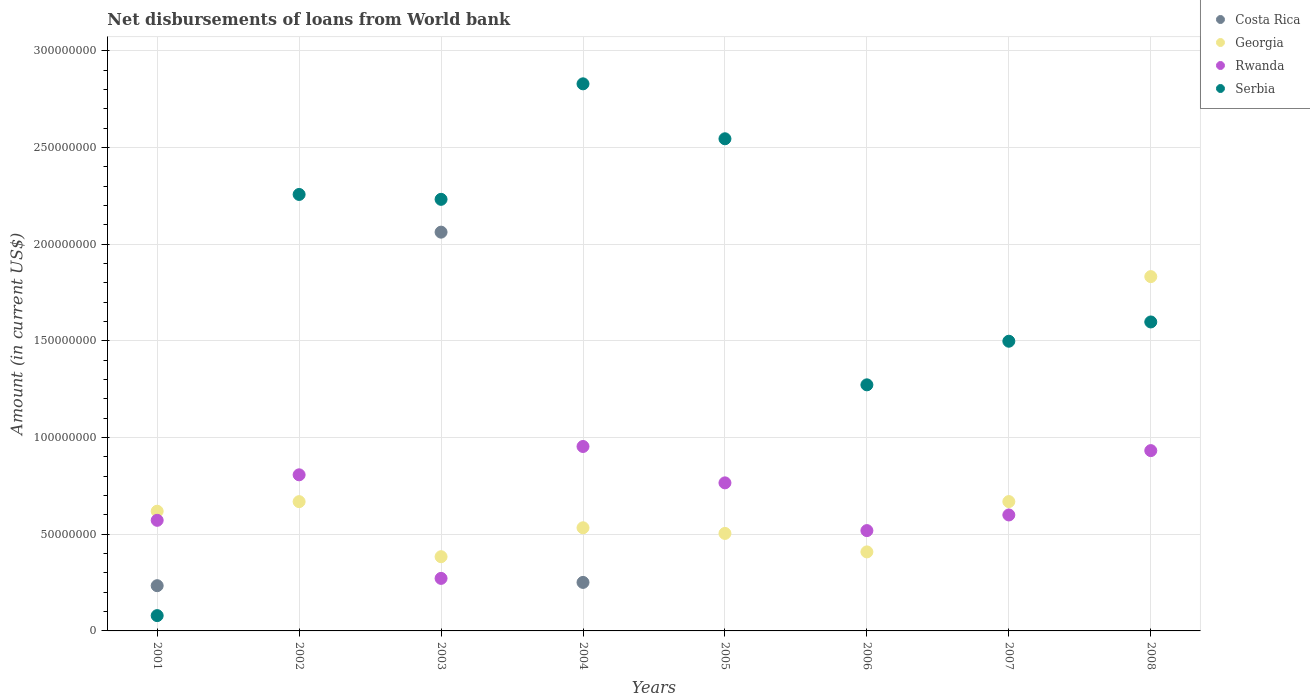What is the amount of loan disbursed from World Bank in Rwanda in 2008?
Your response must be concise. 9.32e+07. Across all years, what is the maximum amount of loan disbursed from World Bank in Georgia?
Make the answer very short. 1.83e+08. Across all years, what is the minimum amount of loan disbursed from World Bank in Rwanda?
Ensure brevity in your answer.  2.72e+07. In which year was the amount of loan disbursed from World Bank in Costa Rica maximum?
Offer a very short reply. 2003. What is the total amount of loan disbursed from World Bank in Serbia in the graph?
Your response must be concise. 1.43e+09. What is the difference between the amount of loan disbursed from World Bank in Rwanda in 2002 and that in 2006?
Offer a terse response. 2.88e+07. What is the difference between the amount of loan disbursed from World Bank in Georgia in 2006 and the amount of loan disbursed from World Bank in Serbia in 2002?
Your answer should be compact. -1.85e+08. What is the average amount of loan disbursed from World Bank in Costa Rica per year?
Give a very brief answer. 3.18e+07. In the year 2001, what is the difference between the amount of loan disbursed from World Bank in Georgia and amount of loan disbursed from World Bank in Costa Rica?
Make the answer very short. 3.85e+07. In how many years, is the amount of loan disbursed from World Bank in Serbia greater than 200000000 US$?
Provide a short and direct response. 4. What is the ratio of the amount of loan disbursed from World Bank in Georgia in 2001 to that in 2005?
Your answer should be very brief. 1.23. Is the amount of loan disbursed from World Bank in Rwanda in 2003 less than that in 2006?
Keep it short and to the point. Yes. Is the difference between the amount of loan disbursed from World Bank in Georgia in 2001 and 2004 greater than the difference between the amount of loan disbursed from World Bank in Costa Rica in 2001 and 2004?
Your response must be concise. Yes. What is the difference between the highest and the second highest amount of loan disbursed from World Bank in Georgia?
Give a very brief answer. 1.16e+08. What is the difference between the highest and the lowest amount of loan disbursed from World Bank in Serbia?
Your answer should be very brief. 2.75e+08. In how many years, is the amount of loan disbursed from World Bank in Georgia greater than the average amount of loan disbursed from World Bank in Georgia taken over all years?
Your answer should be compact. 1. Is the sum of the amount of loan disbursed from World Bank in Rwanda in 2004 and 2008 greater than the maximum amount of loan disbursed from World Bank in Georgia across all years?
Make the answer very short. Yes. Is it the case that in every year, the sum of the amount of loan disbursed from World Bank in Serbia and amount of loan disbursed from World Bank in Costa Rica  is greater than the sum of amount of loan disbursed from World Bank in Rwanda and amount of loan disbursed from World Bank in Georgia?
Offer a terse response. No. Is it the case that in every year, the sum of the amount of loan disbursed from World Bank in Serbia and amount of loan disbursed from World Bank in Georgia  is greater than the amount of loan disbursed from World Bank in Rwanda?
Your answer should be very brief. Yes. What is the difference between two consecutive major ticks on the Y-axis?
Offer a terse response. 5.00e+07. Are the values on the major ticks of Y-axis written in scientific E-notation?
Your answer should be compact. No. Where does the legend appear in the graph?
Offer a very short reply. Top right. How many legend labels are there?
Your answer should be compact. 4. What is the title of the graph?
Give a very brief answer. Net disbursements of loans from World bank. What is the label or title of the X-axis?
Offer a very short reply. Years. What is the label or title of the Y-axis?
Your response must be concise. Amount (in current US$). What is the Amount (in current US$) in Costa Rica in 2001?
Your response must be concise. 2.34e+07. What is the Amount (in current US$) of Georgia in 2001?
Give a very brief answer. 6.19e+07. What is the Amount (in current US$) of Rwanda in 2001?
Ensure brevity in your answer.  5.72e+07. What is the Amount (in current US$) in Serbia in 2001?
Provide a short and direct response. 7.92e+06. What is the Amount (in current US$) of Georgia in 2002?
Offer a very short reply. 6.69e+07. What is the Amount (in current US$) in Rwanda in 2002?
Keep it short and to the point. 8.07e+07. What is the Amount (in current US$) in Serbia in 2002?
Keep it short and to the point. 2.26e+08. What is the Amount (in current US$) of Costa Rica in 2003?
Keep it short and to the point. 2.06e+08. What is the Amount (in current US$) in Georgia in 2003?
Your answer should be compact. 3.84e+07. What is the Amount (in current US$) in Rwanda in 2003?
Your response must be concise. 2.72e+07. What is the Amount (in current US$) of Serbia in 2003?
Keep it short and to the point. 2.23e+08. What is the Amount (in current US$) in Costa Rica in 2004?
Offer a very short reply. 2.51e+07. What is the Amount (in current US$) in Georgia in 2004?
Offer a very short reply. 5.33e+07. What is the Amount (in current US$) of Rwanda in 2004?
Give a very brief answer. 9.54e+07. What is the Amount (in current US$) in Serbia in 2004?
Give a very brief answer. 2.83e+08. What is the Amount (in current US$) in Georgia in 2005?
Offer a very short reply. 5.04e+07. What is the Amount (in current US$) of Rwanda in 2005?
Offer a terse response. 7.66e+07. What is the Amount (in current US$) in Serbia in 2005?
Offer a terse response. 2.55e+08. What is the Amount (in current US$) of Costa Rica in 2006?
Make the answer very short. 0. What is the Amount (in current US$) in Georgia in 2006?
Offer a very short reply. 4.09e+07. What is the Amount (in current US$) of Rwanda in 2006?
Make the answer very short. 5.19e+07. What is the Amount (in current US$) in Serbia in 2006?
Your response must be concise. 1.27e+08. What is the Amount (in current US$) of Georgia in 2007?
Your answer should be very brief. 6.69e+07. What is the Amount (in current US$) in Rwanda in 2007?
Provide a short and direct response. 6.00e+07. What is the Amount (in current US$) of Serbia in 2007?
Make the answer very short. 1.50e+08. What is the Amount (in current US$) of Georgia in 2008?
Provide a succinct answer. 1.83e+08. What is the Amount (in current US$) of Rwanda in 2008?
Make the answer very short. 9.32e+07. What is the Amount (in current US$) in Serbia in 2008?
Ensure brevity in your answer.  1.60e+08. Across all years, what is the maximum Amount (in current US$) of Costa Rica?
Your response must be concise. 2.06e+08. Across all years, what is the maximum Amount (in current US$) in Georgia?
Give a very brief answer. 1.83e+08. Across all years, what is the maximum Amount (in current US$) in Rwanda?
Provide a short and direct response. 9.54e+07. Across all years, what is the maximum Amount (in current US$) of Serbia?
Ensure brevity in your answer.  2.83e+08. Across all years, what is the minimum Amount (in current US$) in Costa Rica?
Offer a very short reply. 0. Across all years, what is the minimum Amount (in current US$) in Georgia?
Your answer should be compact. 3.84e+07. Across all years, what is the minimum Amount (in current US$) of Rwanda?
Offer a terse response. 2.72e+07. Across all years, what is the minimum Amount (in current US$) in Serbia?
Provide a short and direct response. 7.92e+06. What is the total Amount (in current US$) of Costa Rica in the graph?
Provide a short and direct response. 2.55e+08. What is the total Amount (in current US$) in Georgia in the graph?
Offer a terse response. 5.62e+08. What is the total Amount (in current US$) in Rwanda in the graph?
Provide a succinct answer. 5.42e+08. What is the total Amount (in current US$) in Serbia in the graph?
Your answer should be compact. 1.43e+09. What is the difference between the Amount (in current US$) of Georgia in 2001 and that in 2002?
Ensure brevity in your answer.  -4.96e+06. What is the difference between the Amount (in current US$) in Rwanda in 2001 and that in 2002?
Provide a succinct answer. -2.35e+07. What is the difference between the Amount (in current US$) of Serbia in 2001 and that in 2002?
Provide a short and direct response. -2.18e+08. What is the difference between the Amount (in current US$) in Costa Rica in 2001 and that in 2003?
Provide a short and direct response. -1.83e+08. What is the difference between the Amount (in current US$) in Georgia in 2001 and that in 2003?
Your answer should be compact. 2.35e+07. What is the difference between the Amount (in current US$) of Rwanda in 2001 and that in 2003?
Your answer should be compact. 3.00e+07. What is the difference between the Amount (in current US$) in Serbia in 2001 and that in 2003?
Give a very brief answer. -2.15e+08. What is the difference between the Amount (in current US$) in Costa Rica in 2001 and that in 2004?
Offer a terse response. -1.70e+06. What is the difference between the Amount (in current US$) of Georgia in 2001 and that in 2004?
Provide a succinct answer. 8.57e+06. What is the difference between the Amount (in current US$) in Rwanda in 2001 and that in 2004?
Ensure brevity in your answer.  -3.82e+07. What is the difference between the Amount (in current US$) in Serbia in 2001 and that in 2004?
Ensure brevity in your answer.  -2.75e+08. What is the difference between the Amount (in current US$) of Georgia in 2001 and that in 2005?
Your answer should be very brief. 1.15e+07. What is the difference between the Amount (in current US$) of Rwanda in 2001 and that in 2005?
Make the answer very short. -1.94e+07. What is the difference between the Amount (in current US$) in Serbia in 2001 and that in 2005?
Your response must be concise. -2.47e+08. What is the difference between the Amount (in current US$) of Georgia in 2001 and that in 2006?
Offer a terse response. 2.10e+07. What is the difference between the Amount (in current US$) of Rwanda in 2001 and that in 2006?
Ensure brevity in your answer.  5.32e+06. What is the difference between the Amount (in current US$) in Serbia in 2001 and that in 2006?
Offer a very short reply. -1.19e+08. What is the difference between the Amount (in current US$) in Georgia in 2001 and that in 2007?
Keep it short and to the point. -4.99e+06. What is the difference between the Amount (in current US$) of Rwanda in 2001 and that in 2007?
Give a very brief answer. -2.77e+06. What is the difference between the Amount (in current US$) of Serbia in 2001 and that in 2007?
Ensure brevity in your answer.  -1.42e+08. What is the difference between the Amount (in current US$) in Georgia in 2001 and that in 2008?
Your response must be concise. -1.21e+08. What is the difference between the Amount (in current US$) in Rwanda in 2001 and that in 2008?
Your response must be concise. -3.60e+07. What is the difference between the Amount (in current US$) of Serbia in 2001 and that in 2008?
Give a very brief answer. -1.52e+08. What is the difference between the Amount (in current US$) of Georgia in 2002 and that in 2003?
Your answer should be compact. 2.85e+07. What is the difference between the Amount (in current US$) in Rwanda in 2002 and that in 2003?
Your response must be concise. 5.36e+07. What is the difference between the Amount (in current US$) in Serbia in 2002 and that in 2003?
Your answer should be very brief. 2.53e+06. What is the difference between the Amount (in current US$) in Georgia in 2002 and that in 2004?
Offer a very short reply. 1.35e+07. What is the difference between the Amount (in current US$) of Rwanda in 2002 and that in 2004?
Give a very brief answer. -1.46e+07. What is the difference between the Amount (in current US$) of Serbia in 2002 and that in 2004?
Provide a short and direct response. -5.72e+07. What is the difference between the Amount (in current US$) in Georgia in 2002 and that in 2005?
Your answer should be compact. 1.64e+07. What is the difference between the Amount (in current US$) of Rwanda in 2002 and that in 2005?
Provide a short and direct response. 4.16e+06. What is the difference between the Amount (in current US$) of Serbia in 2002 and that in 2005?
Offer a terse response. -2.88e+07. What is the difference between the Amount (in current US$) of Georgia in 2002 and that in 2006?
Provide a short and direct response. 2.60e+07. What is the difference between the Amount (in current US$) of Rwanda in 2002 and that in 2006?
Offer a terse response. 2.88e+07. What is the difference between the Amount (in current US$) of Serbia in 2002 and that in 2006?
Provide a succinct answer. 9.85e+07. What is the difference between the Amount (in current US$) of Georgia in 2002 and that in 2007?
Your answer should be compact. -2.80e+04. What is the difference between the Amount (in current US$) in Rwanda in 2002 and that in 2007?
Ensure brevity in your answer.  2.08e+07. What is the difference between the Amount (in current US$) of Serbia in 2002 and that in 2007?
Your response must be concise. 7.59e+07. What is the difference between the Amount (in current US$) in Georgia in 2002 and that in 2008?
Your response must be concise. -1.16e+08. What is the difference between the Amount (in current US$) of Rwanda in 2002 and that in 2008?
Offer a very short reply. -1.25e+07. What is the difference between the Amount (in current US$) in Serbia in 2002 and that in 2008?
Offer a very short reply. 6.59e+07. What is the difference between the Amount (in current US$) in Costa Rica in 2003 and that in 2004?
Ensure brevity in your answer.  1.81e+08. What is the difference between the Amount (in current US$) in Georgia in 2003 and that in 2004?
Make the answer very short. -1.50e+07. What is the difference between the Amount (in current US$) of Rwanda in 2003 and that in 2004?
Make the answer very short. -6.82e+07. What is the difference between the Amount (in current US$) in Serbia in 2003 and that in 2004?
Keep it short and to the point. -5.97e+07. What is the difference between the Amount (in current US$) in Georgia in 2003 and that in 2005?
Offer a very short reply. -1.20e+07. What is the difference between the Amount (in current US$) of Rwanda in 2003 and that in 2005?
Your response must be concise. -4.94e+07. What is the difference between the Amount (in current US$) of Serbia in 2003 and that in 2005?
Make the answer very short. -3.13e+07. What is the difference between the Amount (in current US$) of Georgia in 2003 and that in 2006?
Your answer should be compact. -2.48e+06. What is the difference between the Amount (in current US$) in Rwanda in 2003 and that in 2006?
Make the answer very short. -2.47e+07. What is the difference between the Amount (in current US$) of Serbia in 2003 and that in 2006?
Offer a very short reply. 9.59e+07. What is the difference between the Amount (in current US$) in Georgia in 2003 and that in 2007?
Provide a succinct answer. -2.85e+07. What is the difference between the Amount (in current US$) in Rwanda in 2003 and that in 2007?
Your response must be concise. -3.28e+07. What is the difference between the Amount (in current US$) in Serbia in 2003 and that in 2007?
Your answer should be very brief. 7.34e+07. What is the difference between the Amount (in current US$) of Georgia in 2003 and that in 2008?
Offer a very short reply. -1.45e+08. What is the difference between the Amount (in current US$) in Rwanda in 2003 and that in 2008?
Your answer should be very brief. -6.61e+07. What is the difference between the Amount (in current US$) of Serbia in 2003 and that in 2008?
Your response must be concise. 6.34e+07. What is the difference between the Amount (in current US$) in Georgia in 2004 and that in 2005?
Offer a terse response. 2.92e+06. What is the difference between the Amount (in current US$) in Rwanda in 2004 and that in 2005?
Keep it short and to the point. 1.88e+07. What is the difference between the Amount (in current US$) of Serbia in 2004 and that in 2005?
Your response must be concise. 2.84e+07. What is the difference between the Amount (in current US$) of Georgia in 2004 and that in 2006?
Your response must be concise. 1.25e+07. What is the difference between the Amount (in current US$) in Rwanda in 2004 and that in 2006?
Your response must be concise. 4.35e+07. What is the difference between the Amount (in current US$) of Serbia in 2004 and that in 2006?
Provide a succinct answer. 1.56e+08. What is the difference between the Amount (in current US$) in Georgia in 2004 and that in 2007?
Make the answer very short. -1.36e+07. What is the difference between the Amount (in current US$) in Rwanda in 2004 and that in 2007?
Keep it short and to the point. 3.54e+07. What is the difference between the Amount (in current US$) in Serbia in 2004 and that in 2007?
Your answer should be compact. 1.33e+08. What is the difference between the Amount (in current US$) of Georgia in 2004 and that in 2008?
Offer a terse response. -1.30e+08. What is the difference between the Amount (in current US$) in Rwanda in 2004 and that in 2008?
Provide a succinct answer. 2.13e+06. What is the difference between the Amount (in current US$) of Serbia in 2004 and that in 2008?
Your response must be concise. 1.23e+08. What is the difference between the Amount (in current US$) of Georgia in 2005 and that in 2006?
Your response must be concise. 9.55e+06. What is the difference between the Amount (in current US$) in Rwanda in 2005 and that in 2006?
Your answer should be compact. 2.47e+07. What is the difference between the Amount (in current US$) of Serbia in 2005 and that in 2006?
Your answer should be compact. 1.27e+08. What is the difference between the Amount (in current US$) of Georgia in 2005 and that in 2007?
Give a very brief answer. -1.65e+07. What is the difference between the Amount (in current US$) in Rwanda in 2005 and that in 2007?
Offer a terse response. 1.66e+07. What is the difference between the Amount (in current US$) in Serbia in 2005 and that in 2007?
Ensure brevity in your answer.  1.05e+08. What is the difference between the Amount (in current US$) in Georgia in 2005 and that in 2008?
Provide a short and direct response. -1.33e+08. What is the difference between the Amount (in current US$) in Rwanda in 2005 and that in 2008?
Ensure brevity in your answer.  -1.67e+07. What is the difference between the Amount (in current US$) in Serbia in 2005 and that in 2008?
Provide a short and direct response. 9.47e+07. What is the difference between the Amount (in current US$) in Georgia in 2006 and that in 2007?
Make the answer very short. -2.60e+07. What is the difference between the Amount (in current US$) of Rwanda in 2006 and that in 2007?
Provide a succinct answer. -8.09e+06. What is the difference between the Amount (in current US$) in Serbia in 2006 and that in 2007?
Your answer should be compact. -2.25e+07. What is the difference between the Amount (in current US$) of Georgia in 2006 and that in 2008?
Offer a very short reply. -1.42e+08. What is the difference between the Amount (in current US$) of Rwanda in 2006 and that in 2008?
Make the answer very short. -4.14e+07. What is the difference between the Amount (in current US$) of Serbia in 2006 and that in 2008?
Keep it short and to the point. -3.25e+07. What is the difference between the Amount (in current US$) in Georgia in 2007 and that in 2008?
Your answer should be very brief. -1.16e+08. What is the difference between the Amount (in current US$) in Rwanda in 2007 and that in 2008?
Your answer should be very brief. -3.33e+07. What is the difference between the Amount (in current US$) in Serbia in 2007 and that in 2008?
Your answer should be very brief. -9.97e+06. What is the difference between the Amount (in current US$) of Costa Rica in 2001 and the Amount (in current US$) of Georgia in 2002?
Your answer should be very brief. -4.35e+07. What is the difference between the Amount (in current US$) in Costa Rica in 2001 and the Amount (in current US$) in Rwanda in 2002?
Your answer should be very brief. -5.73e+07. What is the difference between the Amount (in current US$) in Costa Rica in 2001 and the Amount (in current US$) in Serbia in 2002?
Your answer should be very brief. -2.02e+08. What is the difference between the Amount (in current US$) in Georgia in 2001 and the Amount (in current US$) in Rwanda in 2002?
Your answer should be very brief. -1.88e+07. What is the difference between the Amount (in current US$) in Georgia in 2001 and the Amount (in current US$) in Serbia in 2002?
Make the answer very short. -1.64e+08. What is the difference between the Amount (in current US$) in Rwanda in 2001 and the Amount (in current US$) in Serbia in 2002?
Ensure brevity in your answer.  -1.69e+08. What is the difference between the Amount (in current US$) of Costa Rica in 2001 and the Amount (in current US$) of Georgia in 2003?
Provide a short and direct response. -1.50e+07. What is the difference between the Amount (in current US$) of Costa Rica in 2001 and the Amount (in current US$) of Rwanda in 2003?
Ensure brevity in your answer.  -3.78e+06. What is the difference between the Amount (in current US$) of Costa Rica in 2001 and the Amount (in current US$) of Serbia in 2003?
Offer a very short reply. -2.00e+08. What is the difference between the Amount (in current US$) in Georgia in 2001 and the Amount (in current US$) in Rwanda in 2003?
Provide a short and direct response. 3.47e+07. What is the difference between the Amount (in current US$) of Georgia in 2001 and the Amount (in current US$) of Serbia in 2003?
Keep it short and to the point. -1.61e+08. What is the difference between the Amount (in current US$) of Rwanda in 2001 and the Amount (in current US$) of Serbia in 2003?
Provide a succinct answer. -1.66e+08. What is the difference between the Amount (in current US$) of Costa Rica in 2001 and the Amount (in current US$) of Georgia in 2004?
Keep it short and to the point. -2.99e+07. What is the difference between the Amount (in current US$) in Costa Rica in 2001 and the Amount (in current US$) in Rwanda in 2004?
Offer a very short reply. -7.20e+07. What is the difference between the Amount (in current US$) in Costa Rica in 2001 and the Amount (in current US$) in Serbia in 2004?
Provide a succinct answer. -2.60e+08. What is the difference between the Amount (in current US$) in Georgia in 2001 and the Amount (in current US$) in Rwanda in 2004?
Ensure brevity in your answer.  -3.35e+07. What is the difference between the Amount (in current US$) of Georgia in 2001 and the Amount (in current US$) of Serbia in 2004?
Keep it short and to the point. -2.21e+08. What is the difference between the Amount (in current US$) of Rwanda in 2001 and the Amount (in current US$) of Serbia in 2004?
Make the answer very short. -2.26e+08. What is the difference between the Amount (in current US$) in Costa Rica in 2001 and the Amount (in current US$) in Georgia in 2005?
Make the answer very short. -2.70e+07. What is the difference between the Amount (in current US$) in Costa Rica in 2001 and the Amount (in current US$) in Rwanda in 2005?
Your response must be concise. -5.32e+07. What is the difference between the Amount (in current US$) in Costa Rica in 2001 and the Amount (in current US$) in Serbia in 2005?
Your response must be concise. -2.31e+08. What is the difference between the Amount (in current US$) in Georgia in 2001 and the Amount (in current US$) in Rwanda in 2005?
Your answer should be very brief. -1.47e+07. What is the difference between the Amount (in current US$) of Georgia in 2001 and the Amount (in current US$) of Serbia in 2005?
Your response must be concise. -1.93e+08. What is the difference between the Amount (in current US$) of Rwanda in 2001 and the Amount (in current US$) of Serbia in 2005?
Keep it short and to the point. -1.97e+08. What is the difference between the Amount (in current US$) in Costa Rica in 2001 and the Amount (in current US$) in Georgia in 2006?
Give a very brief answer. -1.75e+07. What is the difference between the Amount (in current US$) of Costa Rica in 2001 and the Amount (in current US$) of Rwanda in 2006?
Give a very brief answer. -2.85e+07. What is the difference between the Amount (in current US$) in Costa Rica in 2001 and the Amount (in current US$) in Serbia in 2006?
Offer a very short reply. -1.04e+08. What is the difference between the Amount (in current US$) of Georgia in 2001 and the Amount (in current US$) of Rwanda in 2006?
Ensure brevity in your answer.  1.00e+07. What is the difference between the Amount (in current US$) of Georgia in 2001 and the Amount (in current US$) of Serbia in 2006?
Your response must be concise. -6.54e+07. What is the difference between the Amount (in current US$) in Rwanda in 2001 and the Amount (in current US$) in Serbia in 2006?
Give a very brief answer. -7.01e+07. What is the difference between the Amount (in current US$) in Costa Rica in 2001 and the Amount (in current US$) in Georgia in 2007?
Ensure brevity in your answer.  -4.35e+07. What is the difference between the Amount (in current US$) of Costa Rica in 2001 and the Amount (in current US$) of Rwanda in 2007?
Provide a short and direct response. -3.66e+07. What is the difference between the Amount (in current US$) of Costa Rica in 2001 and the Amount (in current US$) of Serbia in 2007?
Ensure brevity in your answer.  -1.26e+08. What is the difference between the Amount (in current US$) of Georgia in 2001 and the Amount (in current US$) of Rwanda in 2007?
Offer a terse response. 1.93e+06. What is the difference between the Amount (in current US$) in Georgia in 2001 and the Amount (in current US$) in Serbia in 2007?
Your response must be concise. -8.79e+07. What is the difference between the Amount (in current US$) in Rwanda in 2001 and the Amount (in current US$) in Serbia in 2007?
Offer a terse response. -9.26e+07. What is the difference between the Amount (in current US$) in Costa Rica in 2001 and the Amount (in current US$) in Georgia in 2008?
Give a very brief answer. -1.60e+08. What is the difference between the Amount (in current US$) in Costa Rica in 2001 and the Amount (in current US$) in Rwanda in 2008?
Your answer should be very brief. -6.99e+07. What is the difference between the Amount (in current US$) of Costa Rica in 2001 and the Amount (in current US$) of Serbia in 2008?
Offer a very short reply. -1.36e+08. What is the difference between the Amount (in current US$) of Georgia in 2001 and the Amount (in current US$) of Rwanda in 2008?
Give a very brief answer. -3.13e+07. What is the difference between the Amount (in current US$) in Georgia in 2001 and the Amount (in current US$) in Serbia in 2008?
Your answer should be compact. -9.79e+07. What is the difference between the Amount (in current US$) in Rwanda in 2001 and the Amount (in current US$) in Serbia in 2008?
Make the answer very short. -1.03e+08. What is the difference between the Amount (in current US$) in Georgia in 2002 and the Amount (in current US$) in Rwanda in 2003?
Offer a terse response. 3.97e+07. What is the difference between the Amount (in current US$) of Georgia in 2002 and the Amount (in current US$) of Serbia in 2003?
Your answer should be very brief. -1.56e+08. What is the difference between the Amount (in current US$) in Rwanda in 2002 and the Amount (in current US$) in Serbia in 2003?
Give a very brief answer. -1.42e+08. What is the difference between the Amount (in current US$) in Georgia in 2002 and the Amount (in current US$) in Rwanda in 2004?
Offer a very short reply. -2.85e+07. What is the difference between the Amount (in current US$) of Georgia in 2002 and the Amount (in current US$) of Serbia in 2004?
Your answer should be very brief. -2.16e+08. What is the difference between the Amount (in current US$) of Rwanda in 2002 and the Amount (in current US$) of Serbia in 2004?
Your response must be concise. -2.02e+08. What is the difference between the Amount (in current US$) in Georgia in 2002 and the Amount (in current US$) in Rwanda in 2005?
Keep it short and to the point. -9.71e+06. What is the difference between the Amount (in current US$) in Georgia in 2002 and the Amount (in current US$) in Serbia in 2005?
Your answer should be compact. -1.88e+08. What is the difference between the Amount (in current US$) in Rwanda in 2002 and the Amount (in current US$) in Serbia in 2005?
Keep it short and to the point. -1.74e+08. What is the difference between the Amount (in current US$) in Georgia in 2002 and the Amount (in current US$) in Rwanda in 2006?
Offer a terse response. 1.50e+07. What is the difference between the Amount (in current US$) in Georgia in 2002 and the Amount (in current US$) in Serbia in 2006?
Provide a short and direct response. -6.04e+07. What is the difference between the Amount (in current US$) of Rwanda in 2002 and the Amount (in current US$) of Serbia in 2006?
Make the answer very short. -4.65e+07. What is the difference between the Amount (in current US$) of Georgia in 2002 and the Amount (in current US$) of Rwanda in 2007?
Your answer should be very brief. 6.89e+06. What is the difference between the Amount (in current US$) of Georgia in 2002 and the Amount (in current US$) of Serbia in 2007?
Offer a terse response. -8.30e+07. What is the difference between the Amount (in current US$) in Rwanda in 2002 and the Amount (in current US$) in Serbia in 2007?
Your response must be concise. -6.91e+07. What is the difference between the Amount (in current US$) of Georgia in 2002 and the Amount (in current US$) of Rwanda in 2008?
Keep it short and to the point. -2.64e+07. What is the difference between the Amount (in current US$) in Georgia in 2002 and the Amount (in current US$) in Serbia in 2008?
Keep it short and to the point. -9.29e+07. What is the difference between the Amount (in current US$) of Rwanda in 2002 and the Amount (in current US$) of Serbia in 2008?
Give a very brief answer. -7.90e+07. What is the difference between the Amount (in current US$) in Costa Rica in 2003 and the Amount (in current US$) in Georgia in 2004?
Provide a short and direct response. 1.53e+08. What is the difference between the Amount (in current US$) in Costa Rica in 2003 and the Amount (in current US$) in Rwanda in 2004?
Keep it short and to the point. 1.11e+08. What is the difference between the Amount (in current US$) of Costa Rica in 2003 and the Amount (in current US$) of Serbia in 2004?
Make the answer very short. -7.67e+07. What is the difference between the Amount (in current US$) of Georgia in 2003 and the Amount (in current US$) of Rwanda in 2004?
Offer a very short reply. -5.70e+07. What is the difference between the Amount (in current US$) of Georgia in 2003 and the Amount (in current US$) of Serbia in 2004?
Ensure brevity in your answer.  -2.45e+08. What is the difference between the Amount (in current US$) of Rwanda in 2003 and the Amount (in current US$) of Serbia in 2004?
Your response must be concise. -2.56e+08. What is the difference between the Amount (in current US$) in Costa Rica in 2003 and the Amount (in current US$) in Georgia in 2005?
Provide a short and direct response. 1.56e+08. What is the difference between the Amount (in current US$) in Costa Rica in 2003 and the Amount (in current US$) in Rwanda in 2005?
Offer a terse response. 1.30e+08. What is the difference between the Amount (in current US$) of Costa Rica in 2003 and the Amount (in current US$) of Serbia in 2005?
Your answer should be very brief. -4.83e+07. What is the difference between the Amount (in current US$) in Georgia in 2003 and the Amount (in current US$) in Rwanda in 2005?
Your answer should be compact. -3.82e+07. What is the difference between the Amount (in current US$) of Georgia in 2003 and the Amount (in current US$) of Serbia in 2005?
Your response must be concise. -2.16e+08. What is the difference between the Amount (in current US$) of Rwanda in 2003 and the Amount (in current US$) of Serbia in 2005?
Your answer should be compact. -2.27e+08. What is the difference between the Amount (in current US$) in Costa Rica in 2003 and the Amount (in current US$) in Georgia in 2006?
Offer a terse response. 1.65e+08. What is the difference between the Amount (in current US$) of Costa Rica in 2003 and the Amount (in current US$) of Rwanda in 2006?
Keep it short and to the point. 1.54e+08. What is the difference between the Amount (in current US$) in Costa Rica in 2003 and the Amount (in current US$) in Serbia in 2006?
Offer a very short reply. 7.90e+07. What is the difference between the Amount (in current US$) in Georgia in 2003 and the Amount (in current US$) in Rwanda in 2006?
Give a very brief answer. -1.35e+07. What is the difference between the Amount (in current US$) in Georgia in 2003 and the Amount (in current US$) in Serbia in 2006?
Provide a short and direct response. -8.89e+07. What is the difference between the Amount (in current US$) of Rwanda in 2003 and the Amount (in current US$) of Serbia in 2006?
Give a very brief answer. -1.00e+08. What is the difference between the Amount (in current US$) in Costa Rica in 2003 and the Amount (in current US$) in Georgia in 2007?
Provide a succinct answer. 1.39e+08. What is the difference between the Amount (in current US$) of Costa Rica in 2003 and the Amount (in current US$) of Rwanda in 2007?
Give a very brief answer. 1.46e+08. What is the difference between the Amount (in current US$) of Costa Rica in 2003 and the Amount (in current US$) of Serbia in 2007?
Offer a terse response. 5.64e+07. What is the difference between the Amount (in current US$) of Georgia in 2003 and the Amount (in current US$) of Rwanda in 2007?
Your answer should be compact. -2.16e+07. What is the difference between the Amount (in current US$) of Georgia in 2003 and the Amount (in current US$) of Serbia in 2007?
Keep it short and to the point. -1.11e+08. What is the difference between the Amount (in current US$) in Rwanda in 2003 and the Amount (in current US$) in Serbia in 2007?
Give a very brief answer. -1.23e+08. What is the difference between the Amount (in current US$) of Costa Rica in 2003 and the Amount (in current US$) of Georgia in 2008?
Give a very brief answer. 2.30e+07. What is the difference between the Amount (in current US$) in Costa Rica in 2003 and the Amount (in current US$) in Rwanda in 2008?
Offer a terse response. 1.13e+08. What is the difference between the Amount (in current US$) in Costa Rica in 2003 and the Amount (in current US$) in Serbia in 2008?
Your response must be concise. 4.64e+07. What is the difference between the Amount (in current US$) of Georgia in 2003 and the Amount (in current US$) of Rwanda in 2008?
Provide a short and direct response. -5.49e+07. What is the difference between the Amount (in current US$) in Georgia in 2003 and the Amount (in current US$) in Serbia in 2008?
Give a very brief answer. -1.21e+08. What is the difference between the Amount (in current US$) in Rwanda in 2003 and the Amount (in current US$) in Serbia in 2008?
Give a very brief answer. -1.33e+08. What is the difference between the Amount (in current US$) in Costa Rica in 2004 and the Amount (in current US$) in Georgia in 2005?
Ensure brevity in your answer.  -2.53e+07. What is the difference between the Amount (in current US$) of Costa Rica in 2004 and the Amount (in current US$) of Rwanda in 2005?
Provide a short and direct response. -5.15e+07. What is the difference between the Amount (in current US$) of Costa Rica in 2004 and the Amount (in current US$) of Serbia in 2005?
Provide a succinct answer. -2.29e+08. What is the difference between the Amount (in current US$) of Georgia in 2004 and the Amount (in current US$) of Rwanda in 2005?
Provide a succinct answer. -2.32e+07. What is the difference between the Amount (in current US$) of Georgia in 2004 and the Amount (in current US$) of Serbia in 2005?
Offer a terse response. -2.01e+08. What is the difference between the Amount (in current US$) of Rwanda in 2004 and the Amount (in current US$) of Serbia in 2005?
Make the answer very short. -1.59e+08. What is the difference between the Amount (in current US$) of Costa Rica in 2004 and the Amount (in current US$) of Georgia in 2006?
Your answer should be compact. -1.58e+07. What is the difference between the Amount (in current US$) of Costa Rica in 2004 and the Amount (in current US$) of Rwanda in 2006?
Offer a terse response. -2.68e+07. What is the difference between the Amount (in current US$) in Costa Rica in 2004 and the Amount (in current US$) in Serbia in 2006?
Keep it short and to the point. -1.02e+08. What is the difference between the Amount (in current US$) in Georgia in 2004 and the Amount (in current US$) in Rwanda in 2006?
Your answer should be compact. 1.45e+06. What is the difference between the Amount (in current US$) in Georgia in 2004 and the Amount (in current US$) in Serbia in 2006?
Ensure brevity in your answer.  -7.39e+07. What is the difference between the Amount (in current US$) of Rwanda in 2004 and the Amount (in current US$) of Serbia in 2006?
Offer a terse response. -3.19e+07. What is the difference between the Amount (in current US$) in Costa Rica in 2004 and the Amount (in current US$) in Georgia in 2007?
Your answer should be compact. -4.18e+07. What is the difference between the Amount (in current US$) in Costa Rica in 2004 and the Amount (in current US$) in Rwanda in 2007?
Keep it short and to the point. -3.49e+07. What is the difference between the Amount (in current US$) of Costa Rica in 2004 and the Amount (in current US$) of Serbia in 2007?
Offer a very short reply. -1.25e+08. What is the difference between the Amount (in current US$) in Georgia in 2004 and the Amount (in current US$) in Rwanda in 2007?
Keep it short and to the point. -6.63e+06. What is the difference between the Amount (in current US$) of Georgia in 2004 and the Amount (in current US$) of Serbia in 2007?
Your answer should be very brief. -9.65e+07. What is the difference between the Amount (in current US$) of Rwanda in 2004 and the Amount (in current US$) of Serbia in 2007?
Provide a short and direct response. -5.44e+07. What is the difference between the Amount (in current US$) in Costa Rica in 2004 and the Amount (in current US$) in Georgia in 2008?
Offer a very short reply. -1.58e+08. What is the difference between the Amount (in current US$) of Costa Rica in 2004 and the Amount (in current US$) of Rwanda in 2008?
Offer a very short reply. -6.82e+07. What is the difference between the Amount (in current US$) in Costa Rica in 2004 and the Amount (in current US$) in Serbia in 2008?
Your answer should be very brief. -1.35e+08. What is the difference between the Amount (in current US$) in Georgia in 2004 and the Amount (in current US$) in Rwanda in 2008?
Provide a short and direct response. -3.99e+07. What is the difference between the Amount (in current US$) in Georgia in 2004 and the Amount (in current US$) in Serbia in 2008?
Your response must be concise. -1.06e+08. What is the difference between the Amount (in current US$) of Rwanda in 2004 and the Amount (in current US$) of Serbia in 2008?
Give a very brief answer. -6.44e+07. What is the difference between the Amount (in current US$) in Georgia in 2005 and the Amount (in current US$) in Rwanda in 2006?
Your response must be concise. -1.46e+06. What is the difference between the Amount (in current US$) in Georgia in 2005 and the Amount (in current US$) in Serbia in 2006?
Keep it short and to the point. -7.68e+07. What is the difference between the Amount (in current US$) of Rwanda in 2005 and the Amount (in current US$) of Serbia in 2006?
Your response must be concise. -5.07e+07. What is the difference between the Amount (in current US$) of Georgia in 2005 and the Amount (in current US$) of Rwanda in 2007?
Provide a short and direct response. -9.55e+06. What is the difference between the Amount (in current US$) in Georgia in 2005 and the Amount (in current US$) in Serbia in 2007?
Offer a terse response. -9.94e+07. What is the difference between the Amount (in current US$) of Rwanda in 2005 and the Amount (in current US$) of Serbia in 2007?
Offer a very short reply. -7.32e+07. What is the difference between the Amount (in current US$) in Georgia in 2005 and the Amount (in current US$) in Rwanda in 2008?
Make the answer very short. -4.28e+07. What is the difference between the Amount (in current US$) in Georgia in 2005 and the Amount (in current US$) in Serbia in 2008?
Keep it short and to the point. -1.09e+08. What is the difference between the Amount (in current US$) of Rwanda in 2005 and the Amount (in current US$) of Serbia in 2008?
Your answer should be compact. -8.32e+07. What is the difference between the Amount (in current US$) in Georgia in 2006 and the Amount (in current US$) in Rwanda in 2007?
Ensure brevity in your answer.  -1.91e+07. What is the difference between the Amount (in current US$) of Georgia in 2006 and the Amount (in current US$) of Serbia in 2007?
Provide a succinct answer. -1.09e+08. What is the difference between the Amount (in current US$) of Rwanda in 2006 and the Amount (in current US$) of Serbia in 2007?
Give a very brief answer. -9.79e+07. What is the difference between the Amount (in current US$) of Georgia in 2006 and the Amount (in current US$) of Rwanda in 2008?
Provide a short and direct response. -5.24e+07. What is the difference between the Amount (in current US$) of Georgia in 2006 and the Amount (in current US$) of Serbia in 2008?
Make the answer very short. -1.19e+08. What is the difference between the Amount (in current US$) in Rwanda in 2006 and the Amount (in current US$) in Serbia in 2008?
Provide a succinct answer. -1.08e+08. What is the difference between the Amount (in current US$) in Georgia in 2007 and the Amount (in current US$) in Rwanda in 2008?
Keep it short and to the point. -2.64e+07. What is the difference between the Amount (in current US$) in Georgia in 2007 and the Amount (in current US$) in Serbia in 2008?
Your answer should be compact. -9.29e+07. What is the difference between the Amount (in current US$) of Rwanda in 2007 and the Amount (in current US$) of Serbia in 2008?
Provide a short and direct response. -9.98e+07. What is the average Amount (in current US$) of Costa Rica per year?
Your response must be concise. 3.18e+07. What is the average Amount (in current US$) of Georgia per year?
Give a very brief answer. 7.02e+07. What is the average Amount (in current US$) in Rwanda per year?
Ensure brevity in your answer.  6.78e+07. What is the average Amount (in current US$) in Serbia per year?
Ensure brevity in your answer.  1.79e+08. In the year 2001, what is the difference between the Amount (in current US$) in Costa Rica and Amount (in current US$) in Georgia?
Make the answer very short. -3.85e+07. In the year 2001, what is the difference between the Amount (in current US$) of Costa Rica and Amount (in current US$) of Rwanda?
Give a very brief answer. -3.38e+07. In the year 2001, what is the difference between the Amount (in current US$) in Costa Rica and Amount (in current US$) in Serbia?
Your response must be concise. 1.55e+07. In the year 2001, what is the difference between the Amount (in current US$) of Georgia and Amount (in current US$) of Rwanda?
Ensure brevity in your answer.  4.70e+06. In the year 2001, what is the difference between the Amount (in current US$) of Georgia and Amount (in current US$) of Serbia?
Offer a terse response. 5.40e+07. In the year 2001, what is the difference between the Amount (in current US$) in Rwanda and Amount (in current US$) in Serbia?
Your answer should be very brief. 4.93e+07. In the year 2002, what is the difference between the Amount (in current US$) in Georgia and Amount (in current US$) in Rwanda?
Make the answer very short. -1.39e+07. In the year 2002, what is the difference between the Amount (in current US$) of Georgia and Amount (in current US$) of Serbia?
Provide a short and direct response. -1.59e+08. In the year 2002, what is the difference between the Amount (in current US$) in Rwanda and Amount (in current US$) in Serbia?
Offer a terse response. -1.45e+08. In the year 2003, what is the difference between the Amount (in current US$) of Costa Rica and Amount (in current US$) of Georgia?
Offer a terse response. 1.68e+08. In the year 2003, what is the difference between the Amount (in current US$) of Costa Rica and Amount (in current US$) of Rwanda?
Provide a succinct answer. 1.79e+08. In the year 2003, what is the difference between the Amount (in current US$) in Costa Rica and Amount (in current US$) in Serbia?
Your answer should be compact. -1.70e+07. In the year 2003, what is the difference between the Amount (in current US$) of Georgia and Amount (in current US$) of Rwanda?
Ensure brevity in your answer.  1.12e+07. In the year 2003, what is the difference between the Amount (in current US$) in Georgia and Amount (in current US$) in Serbia?
Ensure brevity in your answer.  -1.85e+08. In the year 2003, what is the difference between the Amount (in current US$) in Rwanda and Amount (in current US$) in Serbia?
Your response must be concise. -1.96e+08. In the year 2004, what is the difference between the Amount (in current US$) of Costa Rica and Amount (in current US$) of Georgia?
Offer a terse response. -2.82e+07. In the year 2004, what is the difference between the Amount (in current US$) of Costa Rica and Amount (in current US$) of Rwanda?
Ensure brevity in your answer.  -7.03e+07. In the year 2004, what is the difference between the Amount (in current US$) in Costa Rica and Amount (in current US$) in Serbia?
Your answer should be very brief. -2.58e+08. In the year 2004, what is the difference between the Amount (in current US$) in Georgia and Amount (in current US$) in Rwanda?
Offer a very short reply. -4.20e+07. In the year 2004, what is the difference between the Amount (in current US$) in Georgia and Amount (in current US$) in Serbia?
Offer a very short reply. -2.30e+08. In the year 2004, what is the difference between the Amount (in current US$) of Rwanda and Amount (in current US$) of Serbia?
Keep it short and to the point. -1.88e+08. In the year 2005, what is the difference between the Amount (in current US$) in Georgia and Amount (in current US$) in Rwanda?
Provide a succinct answer. -2.61e+07. In the year 2005, what is the difference between the Amount (in current US$) of Georgia and Amount (in current US$) of Serbia?
Make the answer very short. -2.04e+08. In the year 2005, what is the difference between the Amount (in current US$) of Rwanda and Amount (in current US$) of Serbia?
Offer a terse response. -1.78e+08. In the year 2006, what is the difference between the Amount (in current US$) in Georgia and Amount (in current US$) in Rwanda?
Your answer should be very brief. -1.10e+07. In the year 2006, what is the difference between the Amount (in current US$) in Georgia and Amount (in current US$) in Serbia?
Offer a very short reply. -8.64e+07. In the year 2006, what is the difference between the Amount (in current US$) of Rwanda and Amount (in current US$) of Serbia?
Your answer should be very brief. -7.54e+07. In the year 2007, what is the difference between the Amount (in current US$) in Georgia and Amount (in current US$) in Rwanda?
Make the answer very short. 6.92e+06. In the year 2007, what is the difference between the Amount (in current US$) in Georgia and Amount (in current US$) in Serbia?
Ensure brevity in your answer.  -8.29e+07. In the year 2007, what is the difference between the Amount (in current US$) of Rwanda and Amount (in current US$) of Serbia?
Your answer should be very brief. -8.98e+07. In the year 2008, what is the difference between the Amount (in current US$) of Georgia and Amount (in current US$) of Rwanda?
Offer a terse response. 9.00e+07. In the year 2008, what is the difference between the Amount (in current US$) in Georgia and Amount (in current US$) in Serbia?
Provide a short and direct response. 2.35e+07. In the year 2008, what is the difference between the Amount (in current US$) of Rwanda and Amount (in current US$) of Serbia?
Provide a succinct answer. -6.65e+07. What is the ratio of the Amount (in current US$) of Georgia in 2001 to that in 2002?
Your answer should be compact. 0.93. What is the ratio of the Amount (in current US$) in Rwanda in 2001 to that in 2002?
Make the answer very short. 0.71. What is the ratio of the Amount (in current US$) of Serbia in 2001 to that in 2002?
Your answer should be very brief. 0.04. What is the ratio of the Amount (in current US$) in Costa Rica in 2001 to that in 2003?
Your answer should be compact. 0.11. What is the ratio of the Amount (in current US$) in Georgia in 2001 to that in 2003?
Offer a very short reply. 1.61. What is the ratio of the Amount (in current US$) in Rwanda in 2001 to that in 2003?
Your answer should be very brief. 2.11. What is the ratio of the Amount (in current US$) in Serbia in 2001 to that in 2003?
Make the answer very short. 0.04. What is the ratio of the Amount (in current US$) of Costa Rica in 2001 to that in 2004?
Your response must be concise. 0.93. What is the ratio of the Amount (in current US$) in Georgia in 2001 to that in 2004?
Your answer should be compact. 1.16. What is the ratio of the Amount (in current US$) in Rwanda in 2001 to that in 2004?
Offer a terse response. 0.6. What is the ratio of the Amount (in current US$) in Serbia in 2001 to that in 2004?
Your response must be concise. 0.03. What is the ratio of the Amount (in current US$) of Georgia in 2001 to that in 2005?
Your answer should be very brief. 1.23. What is the ratio of the Amount (in current US$) in Rwanda in 2001 to that in 2005?
Offer a terse response. 0.75. What is the ratio of the Amount (in current US$) of Serbia in 2001 to that in 2005?
Give a very brief answer. 0.03. What is the ratio of the Amount (in current US$) of Georgia in 2001 to that in 2006?
Ensure brevity in your answer.  1.51. What is the ratio of the Amount (in current US$) in Rwanda in 2001 to that in 2006?
Offer a very short reply. 1.1. What is the ratio of the Amount (in current US$) of Serbia in 2001 to that in 2006?
Provide a succinct answer. 0.06. What is the ratio of the Amount (in current US$) in Georgia in 2001 to that in 2007?
Your response must be concise. 0.93. What is the ratio of the Amount (in current US$) in Rwanda in 2001 to that in 2007?
Provide a succinct answer. 0.95. What is the ratio of the Amount (in current US$) in Serbia in 2001 to that in 2007?
Your answer should be compact. 0.05. What is the ratio of the Amount (in current US$) in Georgia in 2001 to that in 2008?
Make the answer very short. 0.34. What is the ratio of the Amount (in current US$) of Rwanda in 2001 to that in 2008?
Your response must be concise. 0.61. What is the ratio of the Amount (in current US$) of Serbia in 2001 to that in 2008?
Provide a short and direct response. 0.05. What is the ratio of the Amount (in current US$) in Georgia in 2002 to that in 2003?
Provide a succinct answer. 1.74. What is the ratio of the Amount (in current US$) of Rwanda in 2002 to that in 2003?
Give a very brief answer. 2.97. What is the ratio of the Amount (in current US$) of Serbia in 2002 to that in 2003?
Offer a terse response. 1.01. What is the ratio of the Amount (in current US$) of Georgia in 2002 to that in 2004?
Provide a succinct answer. 1.25. What is the ratio of the Amount (in current US$) in Rwanda in 2002 to that in 2004?
Ensure brevity in your answer.  0.85. What is the ratio of the Amount (in current US$) of Serbia in 2002 to that in 2004?
Provide a succinct answer. 0.8. What is the ratio of the Amount (in current US$) of Georgia in 2002 to that in 2005?
Ensure brevity in your answer.  1.33. What is the ratio of the Amount (in current US$) of Rwanda in 2002 to that in 2005?
Provide a short and direct response. 1.05. What is the ratio of the Amount (in current US$) in Serbia in 2002 to that in 2005?
Offer a very short reply. 0.89. What is the ratio of the Amount (in current US$) of Georgia in 2002 to that in 2006?
Provide a short and direct response. 1.64. What is the ratio of the Amount (in current US$) in Rwanda in 2002 to that in 2006?
Your response must be concise. 1.56. What is the ratio of the Amount (in current US$) of Serbia in 2002 to that in 2006?
Your answer should be very brief. 1.77. What is the ratio of the Amount (in current US$) of Rwanda in 2002 to that in 2007?
Keep it short and to the point. 1.35. What is the ratio of the Amount (in current US$) of Serbia in 2002 to that in 2007?
Give a very brief answer. 1.51. What is the ratio of the Amount (in current US$) of Georgia in 2002 to that in 2008?
Your answer should be very brief. 0.36. What is the ratio of the Amount (in current US$) of Rwanda in 2002 to that in 2008?
Make the answer very short. 0.87. What is the ratio of the Amount (in current US$) in Serbia in 2002 to that in 2008?
Provide a succinct answer. 1.41. What is the ratio of the Amount (in current US$) in Costa Rica in 2003 to that in 2004?
Provide a short and direct response. 8.22. What is the ratio of the Amount (in current US$) of Georgia in 2003 to that in 2004?
Give a very brief answer. 0.72. What is the ratio of the Amount (in current US$) of Rwanda in 2003 to that in 2004?
Ensure brevity in your answer.  0.28. What is the ratio of the Amount (in current US$) in Serbia in 2003 to that in 2004?
Offer a very short reply. 0.79. What is the ratio of the Amount (in current US$) of Georgia in 2003 to that in 2005?
Ensure brevity in your answer.  0.76. What is the ratio of the Amount (in current US$) of Rwanda in 2003 to that in 2005?
Give a very brief answer. 0.35. What is the ratio of the Amount (in current US$) in Serbia in 2003 to that in 2005?
Offer a very short reply. 0.88. What is the ratio of the Amount (in current US$) of Georgia in 2003 to that in 2006?
Your answer should be very brief. 0.94. What is the ratio of the Amount (in current US$) of Rwanda in 2003 to that in 2006?
Your response must be concise. 0.52. What is the ratio of the Amount (in current US$) in Serbia in 2003 to that in 2006?
Give a very brief answer. 1.75. What is the ratio of the Amount (in current US$) in Georgia in 2003 to that in 2007?
Your response must be concise. 0.57. What is the ratio of the Amount (in current US$) of Rwanda in 2003 to that in 2007?
Your answer should be compact. 0.45. What is the ratio of the Amount (in current US$) in Serbia in 2003 to that in 2007?
Give a very brief answer. 1.49. What is the ratio of the Amount (in current US$) in Georgia in 2003 to that in 2008?
Offer a very short reply. 0.21. What is the ratio of the Amount (in current US$) of Rwanda in 2003 to that in 2008?
Provide a short and direct response. 0.29. What is the ratio of the Amount (in current US$) in Serbia in 2003 to that in 2008?
Offer a very short reply. 1.4. What is the ratio of the Amount (in current US$) of Georgia in 2004 to that in 2005?
Your answer should be compact. 1.06. What is the ratio of the Amount (in current US$) of Rwanda in 2004 to that in 2005?
Your response must be concise. 1.25. What is the ratio of the Amount (in current US$) in Serbia in 2004 to that in 2005?
Your answer should be compact. 1.11. What is the ratio of the Amount (in current US$) in Georgia in 2004 to that in 2006?
Your answer should be very brief. 1.31. What is the ratio of the Amount (in current US$) in Rwanda in 2004 to that in 2006?
Your answer should be compact. 1.84. What is the ratio of the Amount (in current US$) in Serbia in 2004 to that in 2006?
Provide a short and direct response. 2.22. What is the ratio of the Amount (in current US$) in Georgia in 2004 to that in 2007?
Give a very brief answer. 0.8. What is the ratio of the Amount (in current US$) of Rwanda in 2004 to that in 2007?
Your answer should be compact. 1.59. What is the ratio of the Amount (in current US$) of Serbia in 2004 to that in 2007?
Your answer should be compact. 1.89. What is the ratio of the Amount (in current US$) in Georgia in 2004 to that in 2008?
Your response must be concise. 0.29. What is the ratio of the Amount (in current US$) in Rwanda in 2004 to that in 2008?
Provide a short and direct response. 1.02. What is the ratio of the Amount (in current US$) in Serbia in 2004 to that in 2008?
Keep it short and to the point. 1.77. What is the ratio of the Amount (in current US$) of Georgia in 2005 to that in 2006?
Ensure brevity in your answer.  1.23. What is the ratio of the Amount (in current US$) of Rwanda in 2005 to that in 2006?
Offer a terse response. 1.48. What is the ratio of the Amount (in current US$) in Serbia in 2005 to that in 2006?
Your response must be concise. 2. What is the ratio of the Amount (in current US$) of Georgia in 2005 to that in 2007?
Provide a succinct answer. 0.75. What is the ratio of the Amount (in current US$) in Rwanda in 2005 to that in 2007?
Your answer should be very brief. 1.28. What is the ratio of the Amount (in current US$) in Serbia in 2005 to that in 2007?
Provide a succinct answer. 1.7. What is the ratio of the Amount (in current US$) in Georgia in 2005 to that in 2008?
Your answer should be very brief. 0.28. What is the ratio of the Amount (in current US$) of Rwanda in 2005 to that in 2008?
Your response must be concise. 0.82. What is the ratio of the Amount (in current US$) in Serbia in 2005 to that in 2008?
Keep it short and to the point. 1.59. What is the ratio of the Amount (in current US$) of Georgia in 2006 to that in 2007?
Offer a very short reply. 0.61. What is the ratio of the Amount (in current US$) of Rwanda in 2006 to that in 2007?
Provide a short and direct response. 0.87. What is the ratio of the Amount (in current US$) of Serbia in 2006 to that in 2007?
Give a very brief answer. 0.85. What is the ratio of the Amount (in current US$) in Georgia in 2006 to that in 2008?
Offer a terse response. 0.22. What is the ratio of the Amount (in current US$) of Rwanda in 2006 to that in 2008?
Your response must be concise. 0.56. What is the ratio of the Amount (in current US$) of Serbia in 2006 to that in 2008?
Make the answer very short. 0.8. What is the ratio of the Amount (in current US$) in Georgia in 2007 to that in 2008?
Keep it short and to the point. 0.36. What is the ratio of the Amount (in current US$) of Rwanda in 2007 to that in 2008?
Offer a terse response. 0.64. What is the ratio of the Amount (in current US$) in Serbia in 2007 to that in 2008?
Provide a short and direct response. 0.94. What is the difference between the highest and the second highest Amount (in current US$) of Costa Rica?
Offer a terse response. 1.81e+08. What is the difference between the highest and the second highest Amount (in current US$) of Georgia?
Give a very brief answer. 1.16e+08. What is the difference between the highest and the second highest Amount (in current US$) of Rwanda?
Your answer should be compact. 2.13e+06. What is the difference between the highest and the second highest Amount (in current US$) of Serbia?
Provide a short and direct response. 2.84e+07. What is the difference between the highest and the lowest Amount (in current US$) of Costa Rica?
Your answer should be very brief. 2.06e+08. What is the difference between the highest and the lowest Amount (in current US$) of Georgia?
Give a very brief answer. 1.45e+08. What is the difference between the highest and the lowest Amount (in current US$) in Rwanda?
Provide a succinct answer. 6.82e+07. What is the difference between the highest and the lowest Amount (in current US$) of Serbia?
Provide a short and direct response. 2.75e+08. 